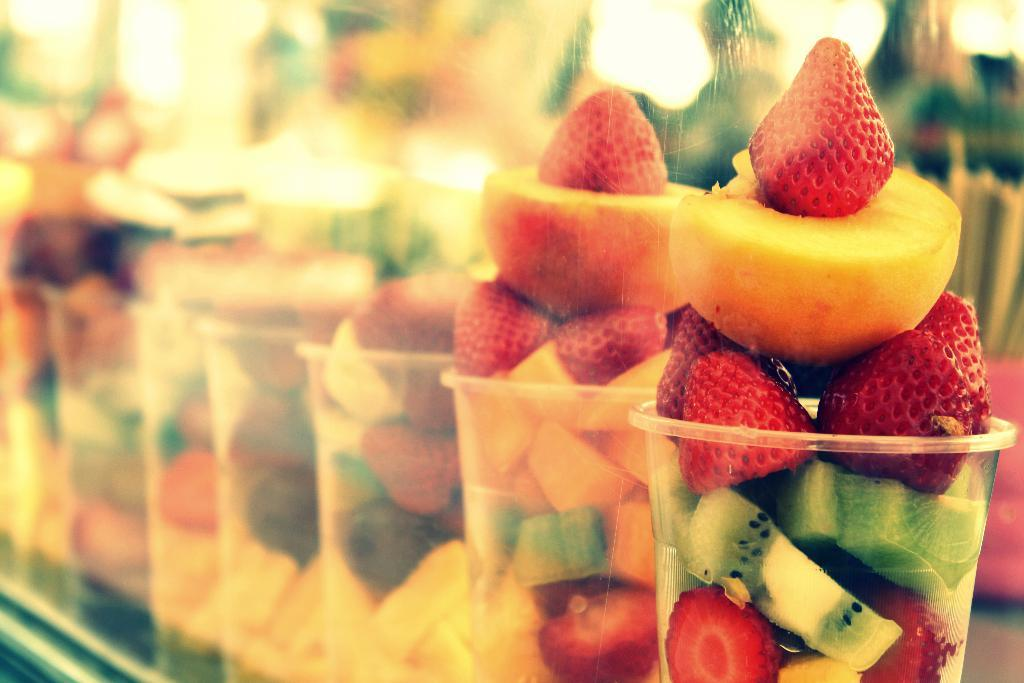What type of food can be seen in the image? There are fruits in the image. How are the fruits prepared in the image? The fruits are cut into pieces. In what container are the cut fruits kept? The cut fruits are kept in a glass. What is the scent of the company in the image? There is no company present in the image, and therefore no scent can be associated with it. 